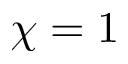Convert formula to latex. <formula><loc_0><loc_0><loc_500><loc_500>\chi = 1</formula> 